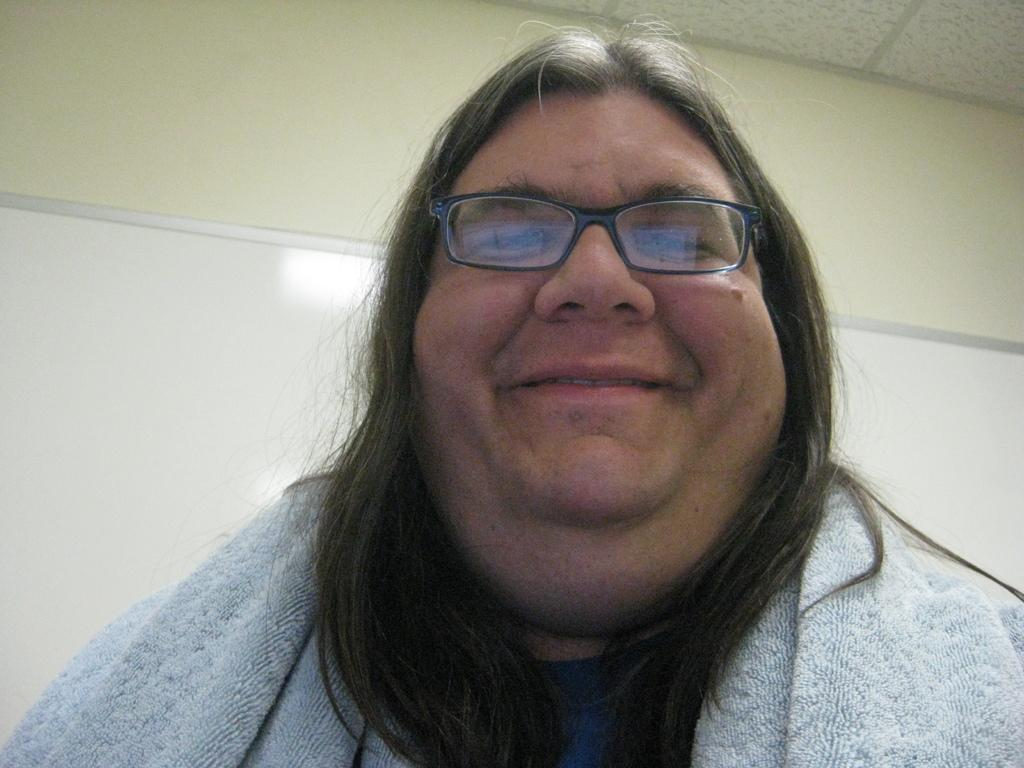What can be seen in the image? There is a person in the image. Can you describe the person's appearance? The person is wearing spectacles and has a towel on their shoulder. How is the person feeling in the image? The person is smiling. What is present in the background of the image? There is a whiteboard in the background, which is attached to a wall. What else can be seen in the background? There is a roof visible in the background. What type of sweater is the secretary wearing in the image? There is no secretary present in the image, and no sweater is visible. 